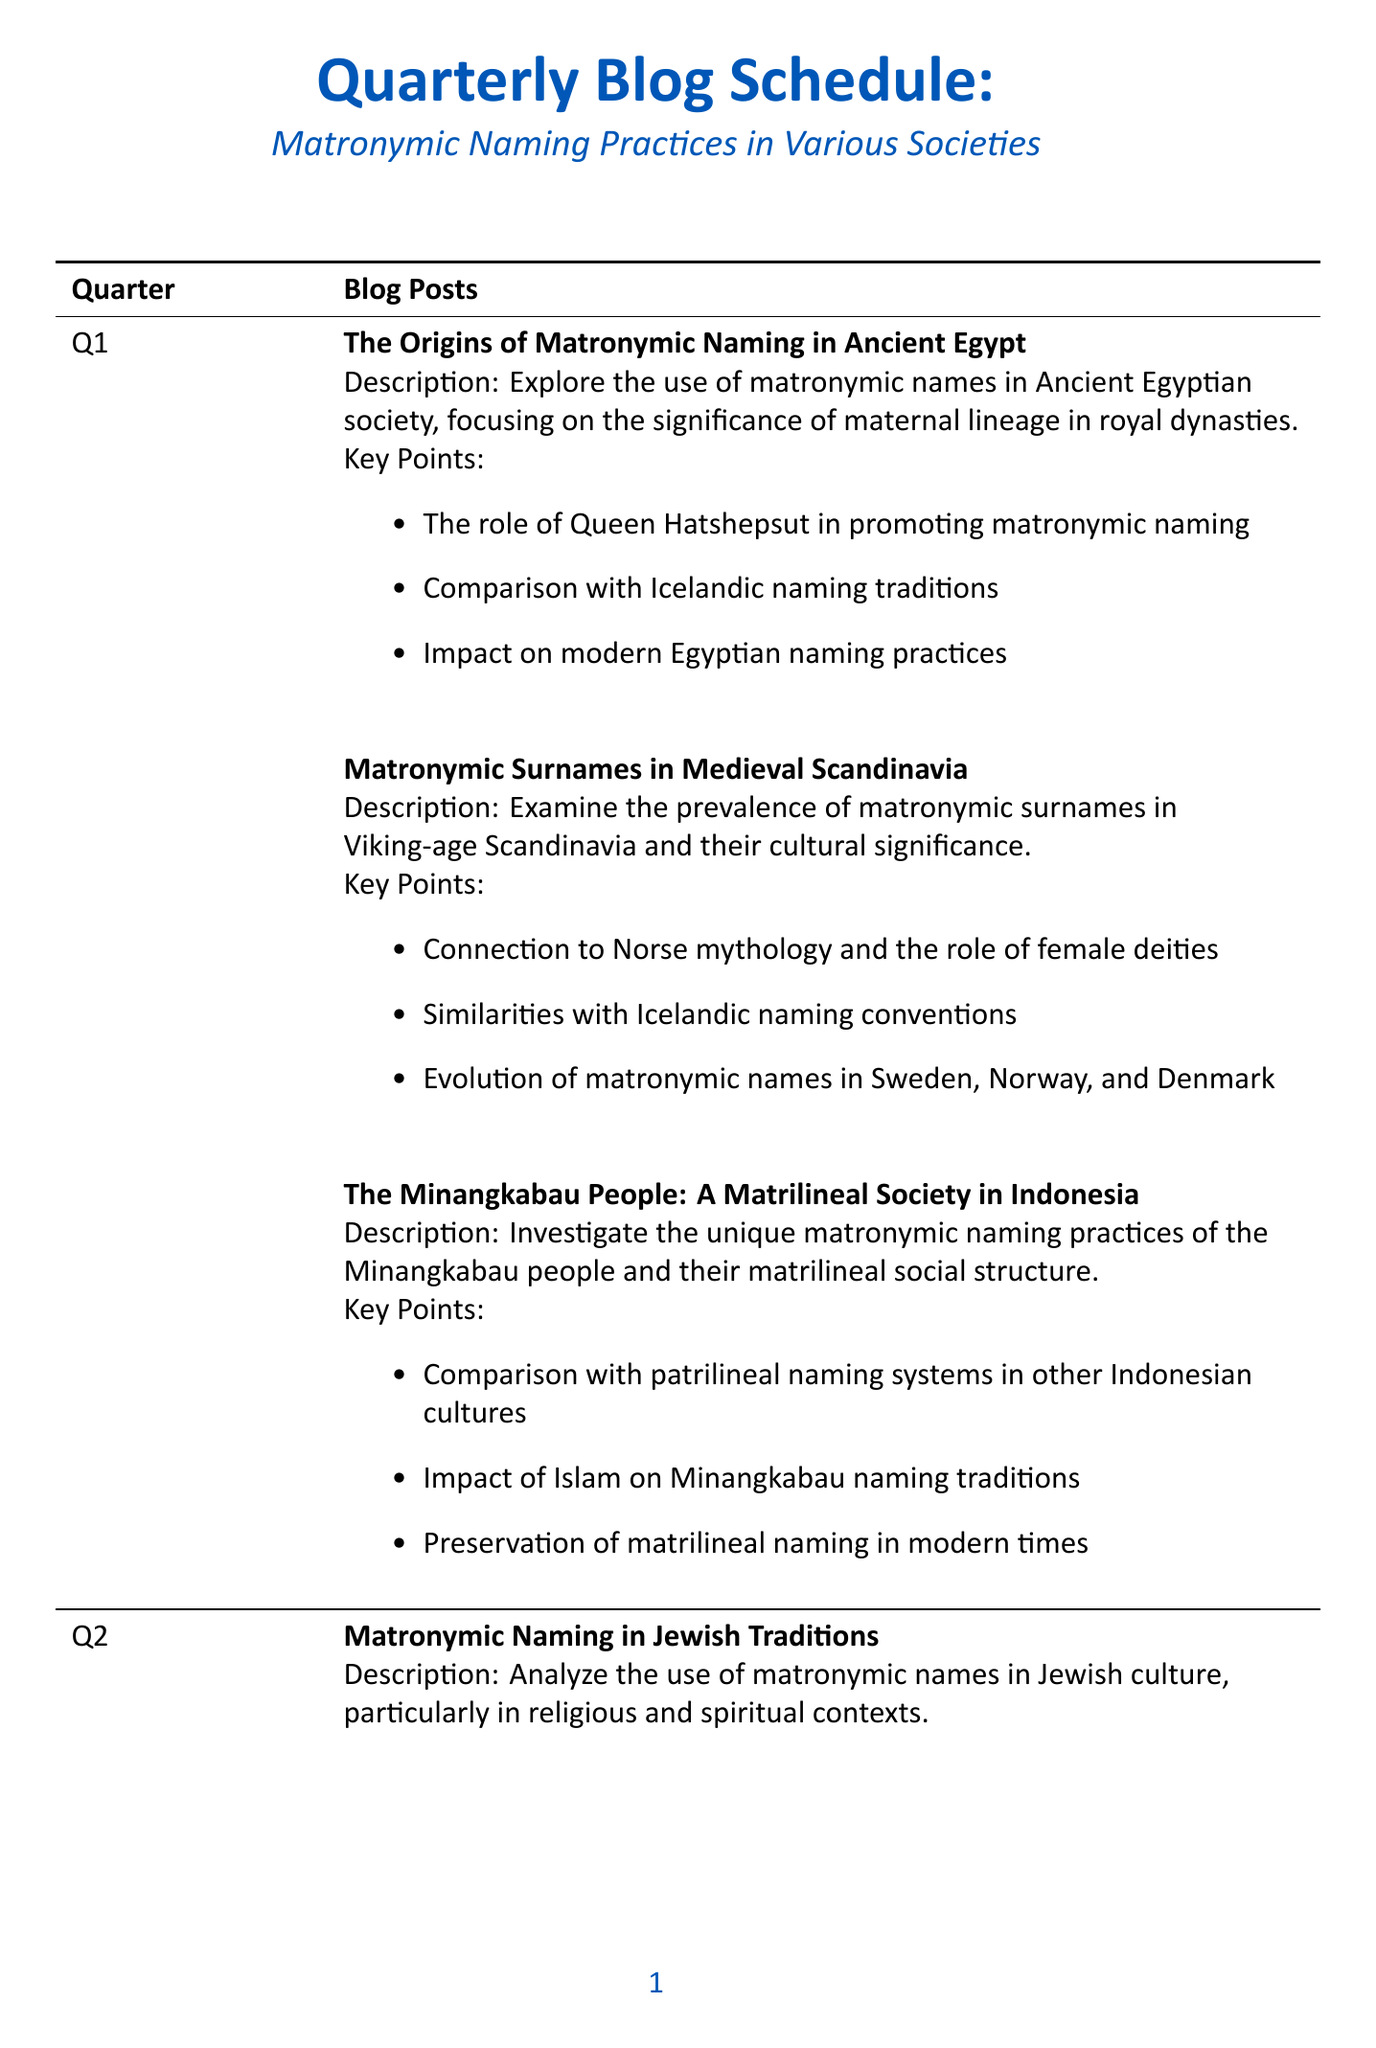What is the title of the first blog post in Q1? The title is listed under Q1, the first blog post is "The Origins of Matronymic Naming in Ancient Egypt."
Answer: The Origins of Matronymic Naming in Ancient Egypt Which society's matronymic naming practices are explored in Q3? The blog post title in Q3 discusses "Matronymic Naming in African Cultures: The Akan People," which is about the Akan people in Ghana and Ivory Coast.
Answer: Akan people How many blog posts are scheduled for Q4? The document lists three blog posts under Q4.
Answer: 3 What is a key point in the blog post about Jewish traditions? One key point listed is "The significance of the Matriarchs in Jewish naming practices."
Answer: The significance of the Matriarchs in Jewish naming practices What pattern do the blog titles in Q2 and Q3 share? Both quarters focus on the significance and impact of matronymic naming practices across different cultures, such as Jewish, Native American, and African cultures.
Answer: Significance and impact of matronymic naming practices Which blog post in Q4 discusses the influence of global changes? The relevant blog post is titled "The Future of Matronymic Naming in a Globalized World."
Answer: The Future of Matronymic Naming in a Globalized World What aspect of naming practices do the titles in Q1 frequently highlight? The titles in Q1 often highlight historical contexts of matronymic naming practices in specific societies, like Ancient Egypt and Scandinavia.
Answer: Historical contexts How is the Icelandic naming system characterized in Q4? The blog post is titled "Icelandic Naming Laws: A Model for Matronymic Equality," indicating a focus on equality in naming traditions.
Answer: Equality in naming traditions 